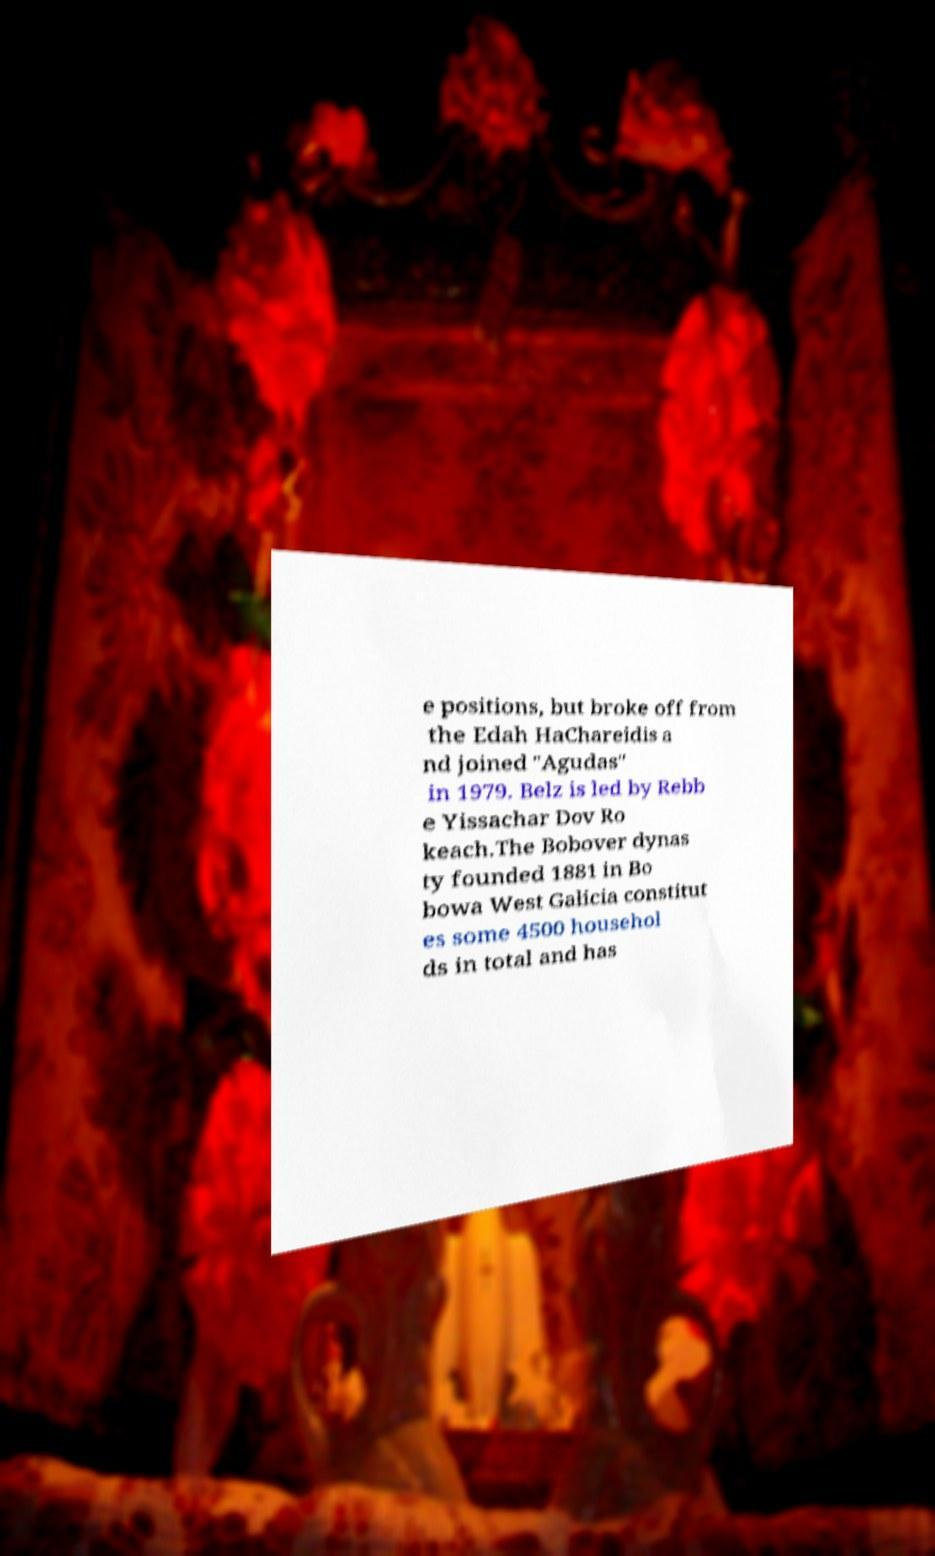Please read and relay the text visible in this image. What does it say? e positions, but broke off from the Edah HaChareidis a nd joined "Agudas" in 1979. Belz is led by Rebb e Yissachar Dov Ro keach.The Bobover dynas ty founded 1881 in Bo bowa West Galicia constitut es some 4500 househol ds in total and has 